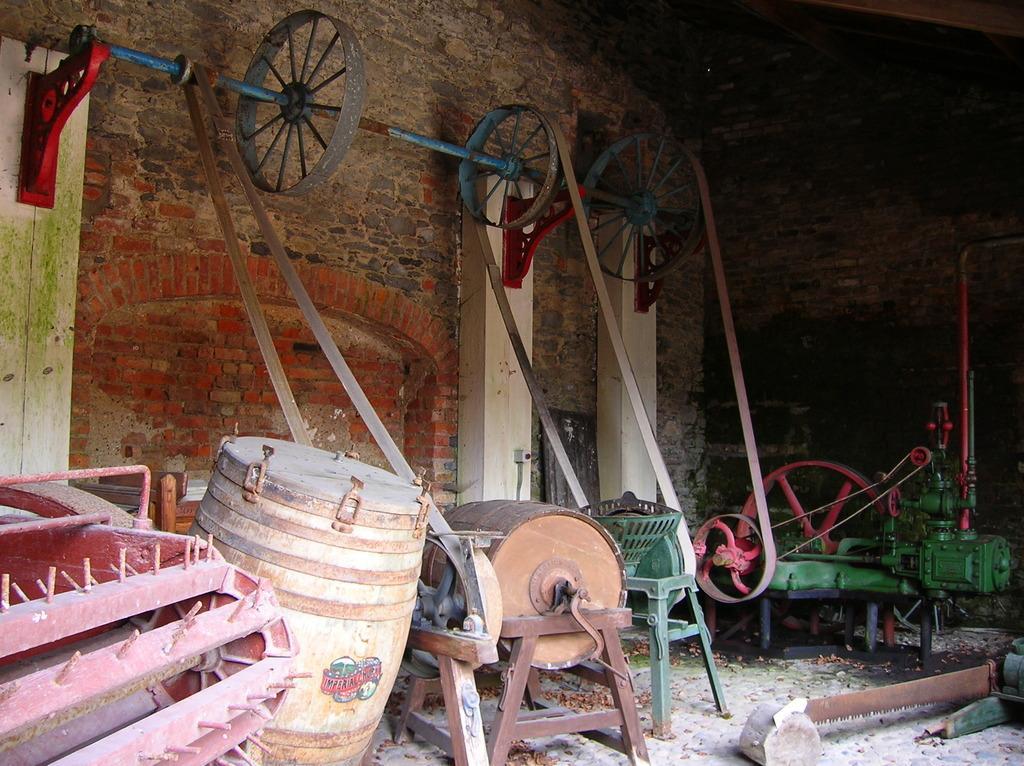Could you give a brief overview of what you see in this image? In this image there are few machines on the floor. Left side there is a machine, beside there is a wine drum. Machines are having belts which are hanged the rod which is fixed to the wall. Rod is having few wheels attached to it. Background there is a brick wall. 